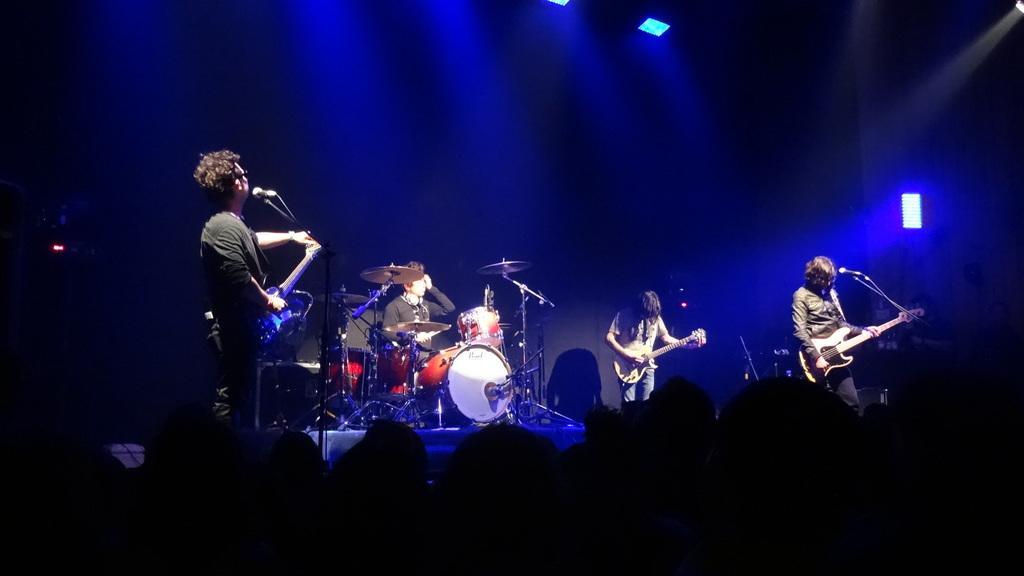In one or two sentences, can you explain what this image depicts? In this image I can see a group of people are playing musical instruments in front of a microphone on stage. 